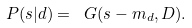Convert formula to latex. <formula><loc_0><loc_0><loc_500><loc_500>P ( s | d ) = \ G ( s - m _ { d } , D ) .</formula> 